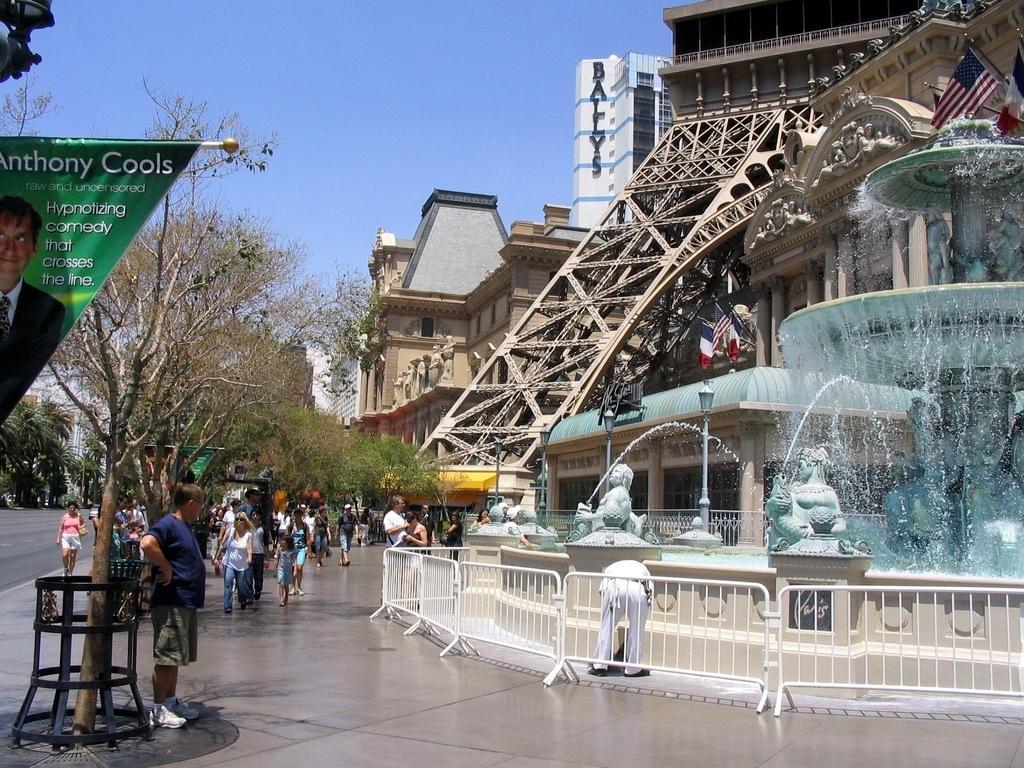Could you give a brief overview of what you see in this image? In this picture we can see the water fountain in the front. Behind there is a Paris tower and some houses. On the left corner we can see some people walking in the pedestrian area and some dry trees. On the top we can see the clear blue sky. 